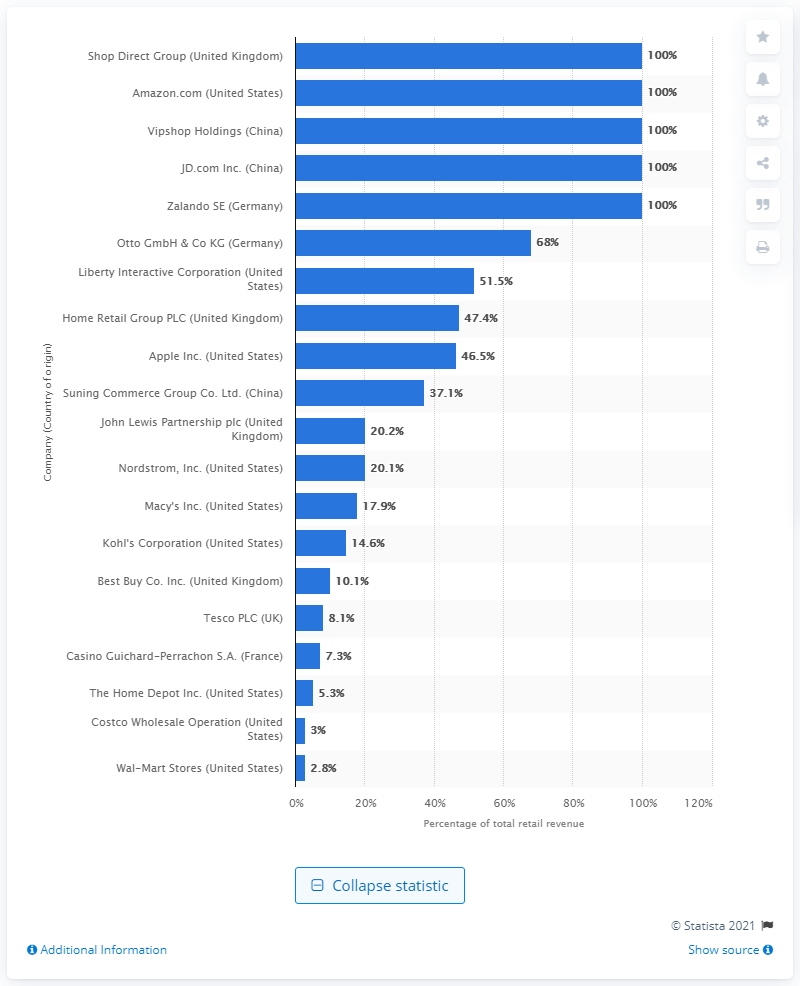Highlight a few significant elements in this photo. In 2015, approximately 100% of Amazon's net product sales were from e-digital sales. 